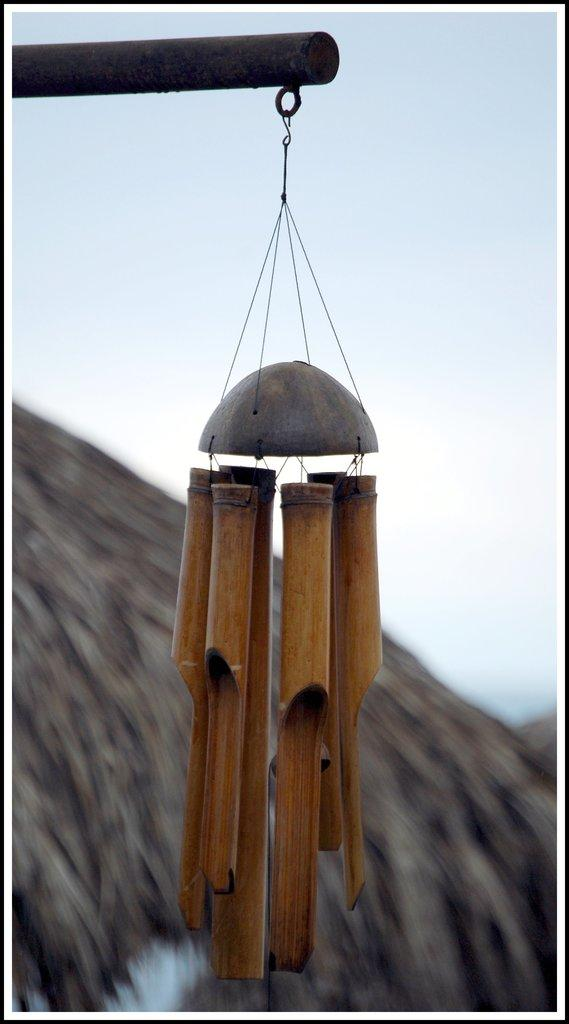What object is the main subject of the image? The main subject of the image is a wooden bell. How has the wooden bell been altered in the image? The wooden bell has been changed to a rod. What can be seen in the distance in the image? The sky is visible in the background of the image. How would you describe the appearance of the background? The background is blurred. How does the wooden bell compare to the coast in the image? There is no coast present in the image, so the wooden bell cannot be compared to it. 